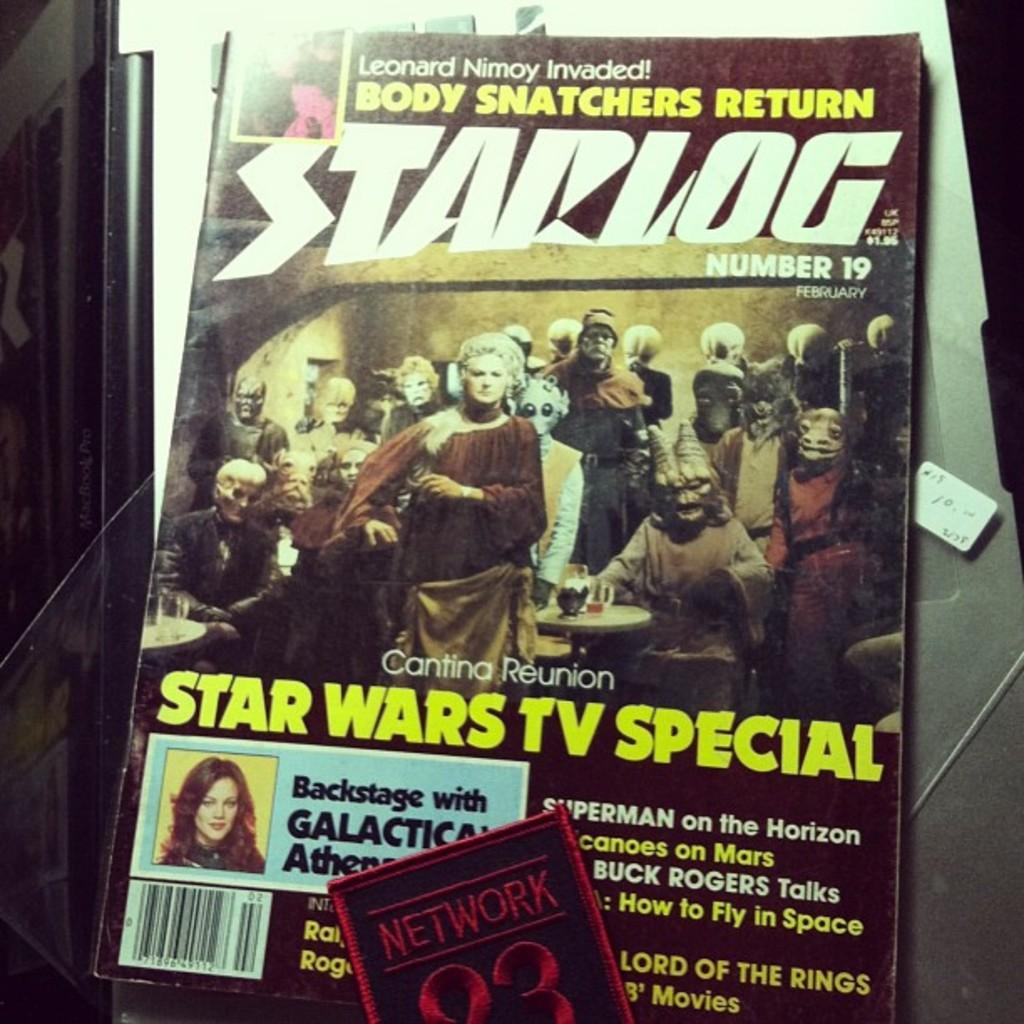What is the main object in the picture? There is a magazine in the picture. What is the name of the magazine? The magazine has the name "Star Log" on it. What type of content can be found in the magazine? The magazine contains images of people. Where is the vase located in the image? There is no vase present in the image. What riddle is solved by the people in the magazine? The images of people in the magazine do not depict them solving a riddle. 